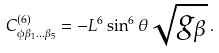<formula> <loc_0><loc_0><loc_500><loc_500>C ^ { ( 6 ) } _ { \phi \beta _ { 1 } \dots \beta _ { 5 } } = - L ^ { 6 } \sin ^ { 6 } { \theta } \sqrt { g _ { \beta } } \, .</formula> 